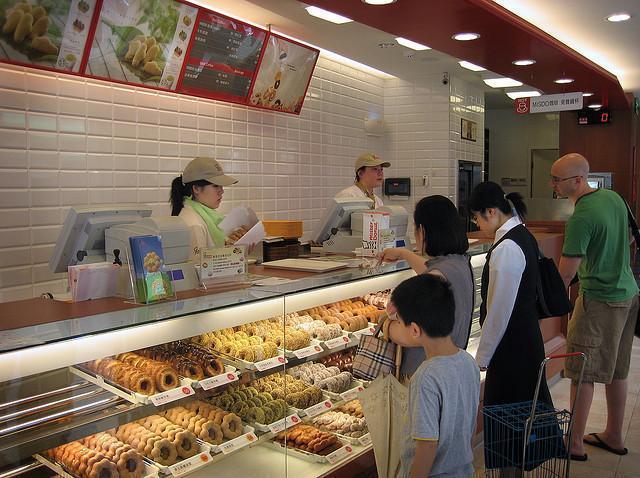In which liquid were most of the shown treats boiled?
Answer the question by selecting the correct answer among the 4 following choices.
Options: Dishwater, oil, petrol, water. Oil. 